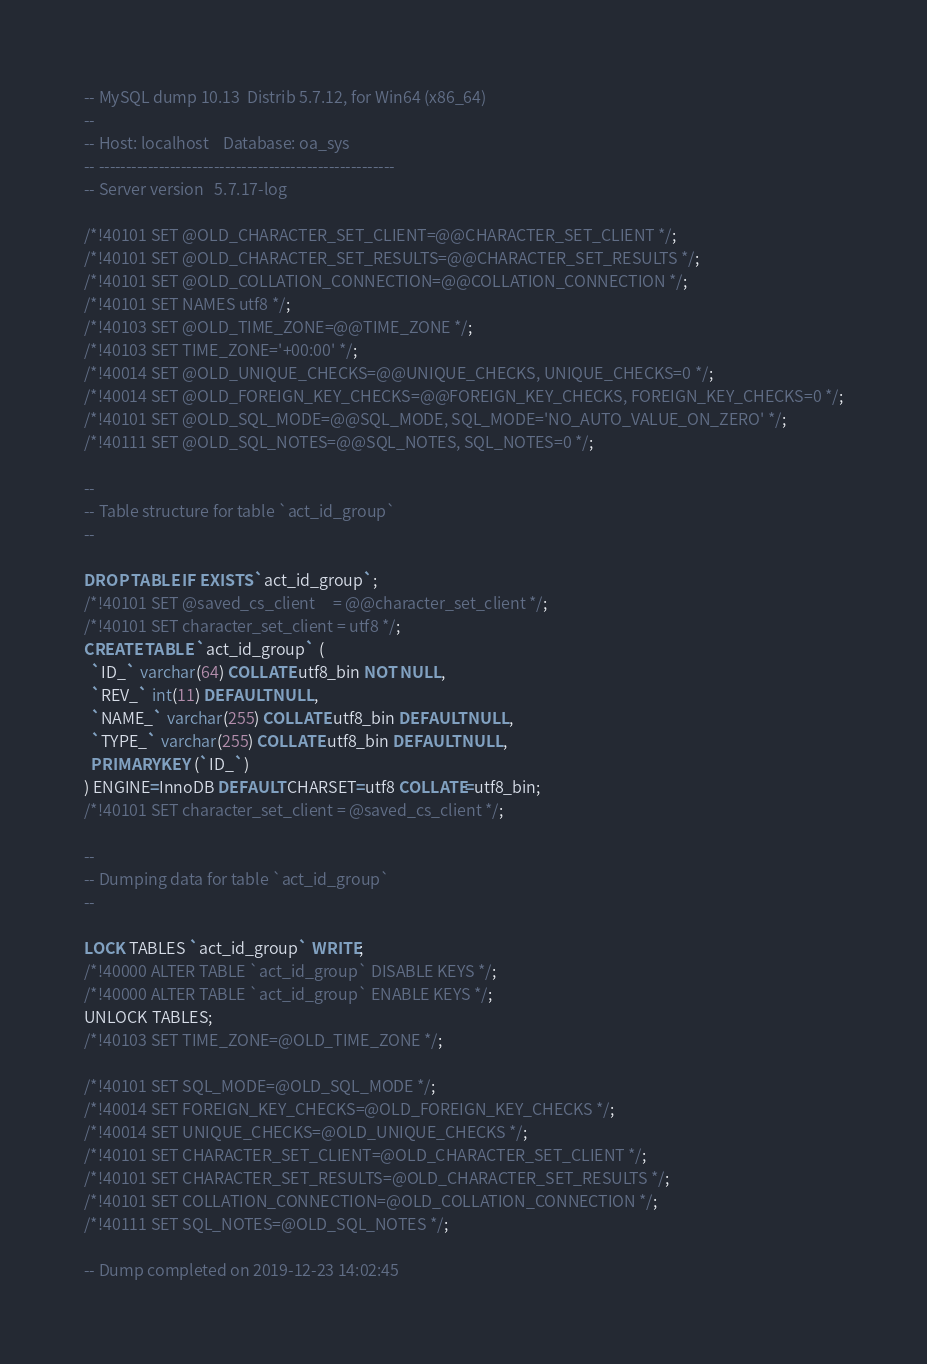Convert code to text. <code><loc_0><loc_0><loc_500><loc_500><_SQL_>-- MySQL dump 10.13  Distrib 5.7.12, for Win64 (x86_64)
--
-- Host: localhost    Database: oa_sys
-- ------------------------------------------------------
-- Server version	5.7.17-log

/*!40101 SET @OLD_CHARACTER_SET_CLIENT=@@CHARACTER_SET_CLIENT */;
/*!40101 SET @OLD_CHARACTER_SET_RESULTS=@@CHARACTER_SET_RESULTS */;
/*!40101 SET @OLD_COLLATION_CONNECTION=@@COLLATION_CONNECTION */;
/*!40101 SET NAMES utf8 */;
/*!40103 SET @OLD_TIME_ZONE=@@TIME_ZONE */;
/*!40103 SET TIME_ZONE='+00:00' */;
/*!40014 SET @OLD_UNIQUE_CHECKS=@@UNIQUE_CHECKS, UNIQUE_CHECKS=0 */;
/*!40014 SET @OLD_FOREIGN_KEY_CHECKS=@@FOREIGN_KEY_CHECKS, FOREIGN_KEY_CHECKS=0 */;
/*!40101 SET @OLD_SQL_MODE=@@SQL_MODE, SQL_MODE='NO_AUTO_VALUE_ON_ZERO' */;
/*!40111 SET @OLD_SQL_NOTES=@@SQL_NOTES, SQL_NOTES=0 */;

--
-- Table structure for table `act_id_group`
--

DROP TABLE IF EXISTS `act_id_group`;
/*!40101 SET @saved_cs_client     = @@character_set_client */;
/*!40101 SET character_set_client = utf8 */;
CREATE TABLE `act_id_group` (
  `ID_` varchar(64) COLLATE utf8_bin NOT NULL,
  `REV_` int(11) DEFAULT NULL,
  `NAME_` varchar(255) COLLATE utf8_bin DEFAULT NULL,
  `TYPE_` varchar(255) COLLATE utf8_bin DEFAULT NULL,
  PRIMARY KEY (`ID_`)
) ENGINE=InnoDB DEFAULT CHARSET=utf8 COLLATE=utf8_bin;
/*!40101 SET character_set_client = @saved_cs_client */;

--
-- Dumping data for table `act_id_group`
--

LOCK TABLES `act_id_group` WRITE;
/*!40000 ALTER TABLE `act_id_group` DISABLE KEYS */;
/*!40000 ALTER TABLE `act_id_group` ENABLE KEYS */;
UNLOCK TABLES;
/*!40103 SET TIME_ZONE=@OLD_TIME_ZONE */;

/*!40101 SET SQL_MODE=@OLD_SQL_MODE */;
/*!40014 SET FOREIGN_KEY_CHECKS=@OLD_FOREIGN_KEY_CHECKS */;
/*!40014 SET UNIQUE_CHECKS=@OLD_UNIQUE_CHECKS */;
/*!40101 SET CHARACTER_SET_CLIENT=@OLD_CHARACTER_SET_CLIENT */;
/*!40101 SET CHARACTER_SET_RESULTS=@OLD_CHARACTER_SET_RESULTS */;
/*!40101 SET COLLATION_CONNECTION=@OLD_COLLATION_CONNECTION */;
/*!40111 SET SQL_NOTES=@OLD_SQL_NOTES */;

-- Dump completed on 2019-12-23 14:02:45
</code> 